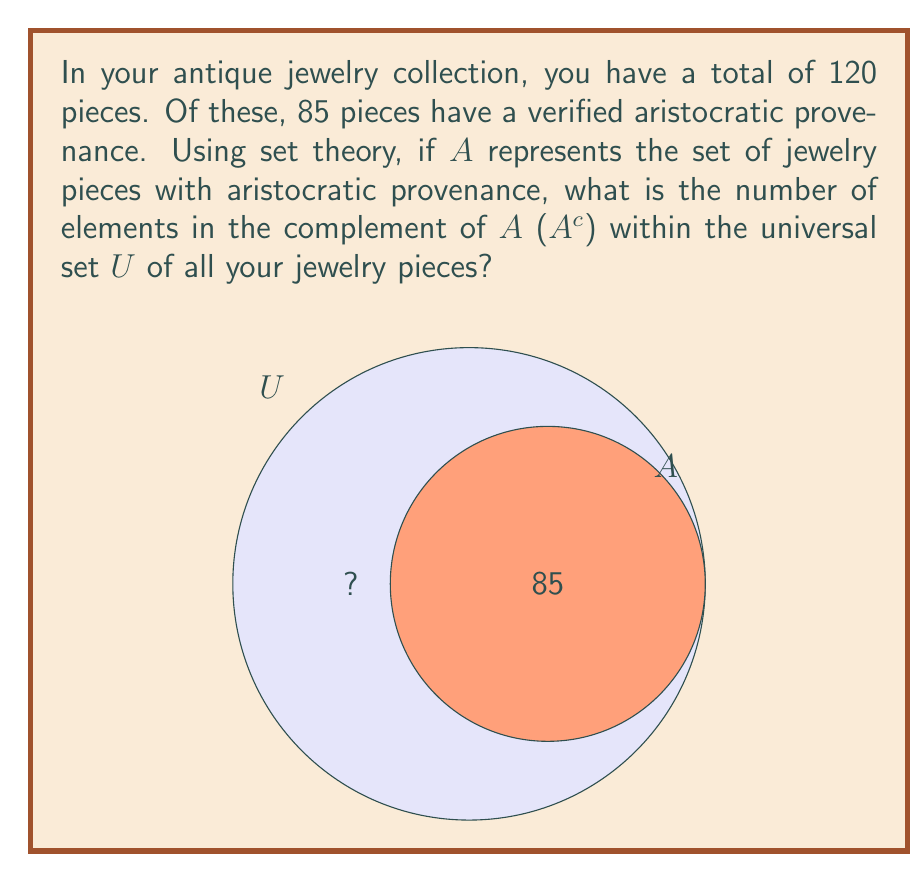Can you solve this math problem? Let's approach this step-by-step:

1) Define our sets:
   U = Universal set (all jewelry pieces)
   A = Set of jewelry pieces with aristocratic provenance
   A^c = Complement of A (non-aristocratic pieces)

2) Given information:
   |U| = 120 (total number of pieces)
   |A| = 85 (pieces with aristocratic provenance)

3) Recall the complement formula:
   |A^c| = |U| - |A|

4) Substitute the known values:
   |A^c| = 120 - 85

5) Calculate:
   |A^c| = 35

Therefore, the number of jewelry pieces without aristocratic provenance (the complement of A) is 35.
Answer: 35 